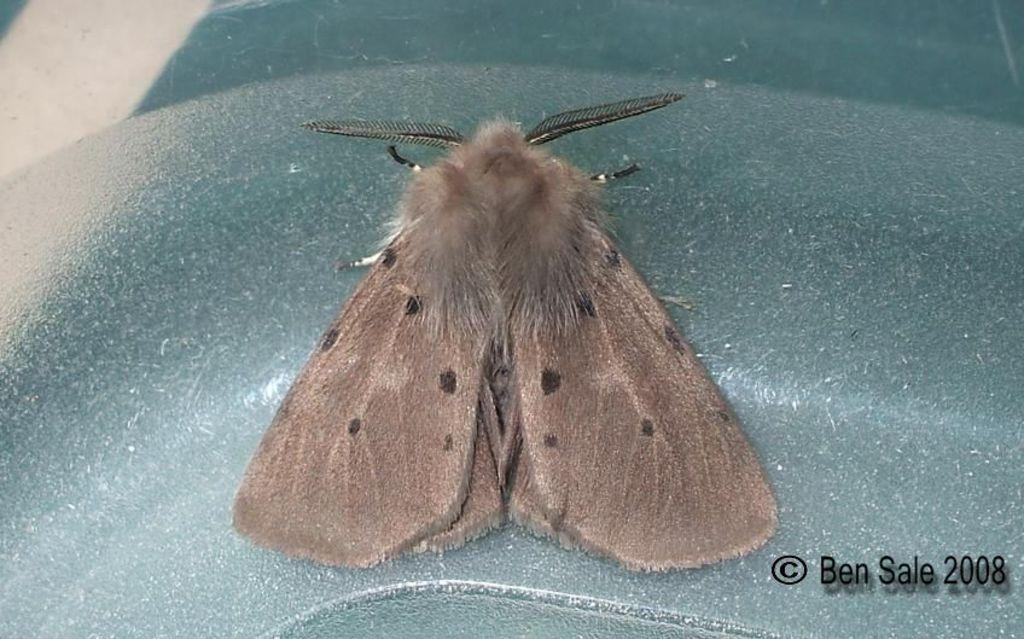What type of insect is in the image? There is a brown color butterfly in the image. What is the butterfly sitting on? The butterfly is sitting on a blue color iron box. What additional text is present at the bottom of the image? There is a small quote at the bottom of the image. Is there any information about the date associated with the quote? Yes, a date is written alongside the quote. How many sticks are being used by the butterfly in the image? There are no sticks present in the image; it features a butterfly sitting on a blue color iron box. What type of planes can be seen flying in the image? There are no planes present in the image; it features a brown color butterfly sitting on a blue color iron box with a quote and a date. 